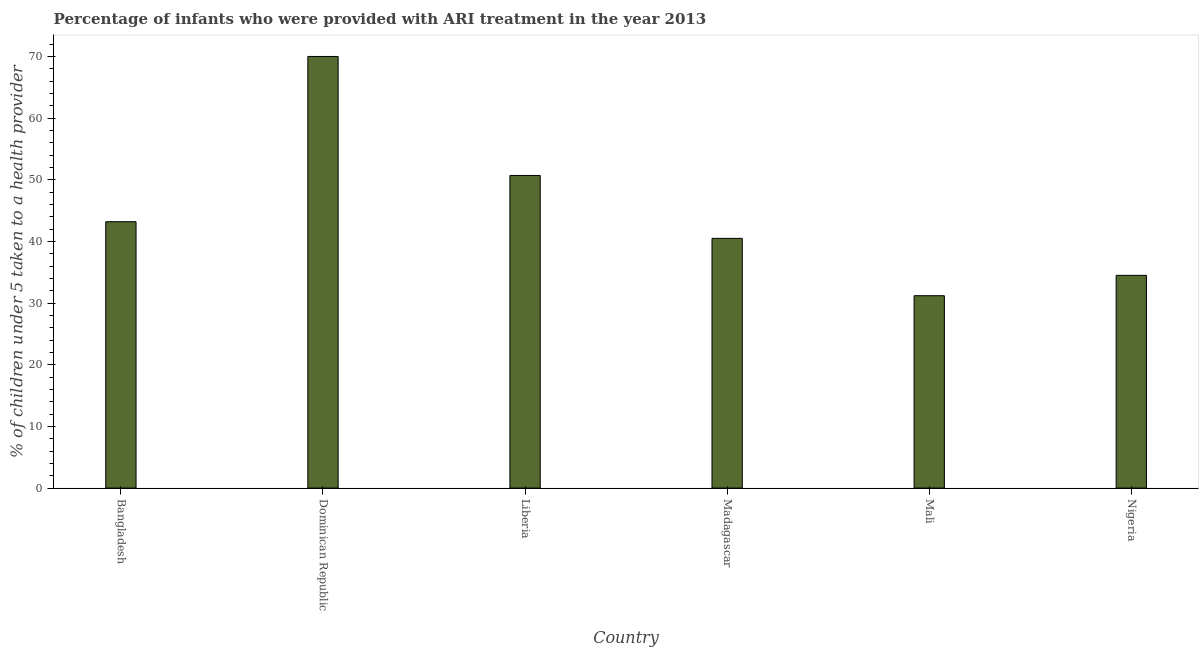Does the graph contain any zero values?
Provide a short and direct response. No. Does the graph contain grids?
Provide a succinct answer. No. What is the title of the graph?
Provide a short and direct response. Percentage of infants who were provided with ARI treatment in the year 2013. What is the label or title of the X-axis?
Give a very brief answer. Country. What is the label or title of the Y-axis?
Provide a short and direct response. % of children under 5 taken to a health provider. What is the percentage of children who were provided with ari treatment in Madagascar?
Offer a very short reply. 40.5. Across all countries, what is the minimum percentage of children who were provided with ari treatment?
Give a very brief answer. 31.2. In which country was the percentage of children who were provided with ari treatment maximum?
Ensure brevity in your answer.  Dominican Republic. In which country was the percentage of children who were provided with ari treatment minimum?
Offer a terse response. Mali. What is the sum of the percentage of children who were provided with ari treatment?
Ensure brevity in your answer.  270.1. What is the average percentage of children who were provided with ari treatment per country?
Make the answer very short. 45.02. What is the median percentage of children who were provided with ari treatment?
Your answer should be very brief. 41.85. In how many countries, is the percentage of children who were provided with ari treatment greater than 60 %?
Your answer should be very brief. 1. What is the ratio of the percentage of children who were provided with ari treatment in Bangladesh to that in Nigeria?
Your response must be concise. 1.25. What is the difference between the highest and the second highest percentage of children who were provided with ari treatment?
Keep it short and to the point. 19.3. Is the sum of the percentage of children who were provided with ari treatment in Madagascar and Mali greater than the maximum percentage of children who were provided with ari treatment across all countries?
Your answer should be compact. Yes. What is the difference between the highest and the lowest percentage of children who were provided with ari treatment?
Give a very brief answer. 38.8. In how many countries, is the percentage of children who were provided with ari treatment greater than the average percentage of children who were provided with ari treatment taken over all countries?
Offer a very short reply. 2. How many bars are there?
Provide a short and direct response. 6. Are all the bars in the graph horizontal?
Your response must be concise. No. How many countries are there in the graph?
Your answer should be very brief. 6. What is the difference between two consecutive major ticks on the Y-axis?
Your answer should be compact. 10. What is the % of children under 5 taken to a health provider in Bangladesh?
Keep it short and to the point. 43.2. What is the % of children under 5 taken to a health provider of Dominican Republic?
Ensure brevity in your answer.  70. What is the % of children under 5 taken to a health provider in Liberia?
Keep it short and to the point. 50.7. What is the % of children under 5 taken to a health provider in Madagascar?
Make the answer very short. 40.5. What is the % of children under 5 taken to a health provider of Mali?
Your answer should be very brief. 31.2. What is the % of children under 5 taken to a health provider in Nigeria?
Your answer should be very brief. 34.5. What is the difference between the % of children under 5 taken to a health provider in Bangladesh and Dominican Republic?
Your answer should be very brief. -26.8. What is the difference between the % of children under 5 taken to a health provider in Bangladesh and Madagascar?
Offer a terse response. 2.7. What is the difference between the % of children under 5 taken to a health provider in Bangladesh and Mali?
Offer a terse response. 12. What is the difference between the % of children under 5 taken to a health provider in Bangladesh and Nigeria?
Provide a succinct answer. 8.7. What is the difference between the % of children under 5 taken to a health provider in Dominican Republic and Liberia?
Your answer should be compact. 19.3. What is the difference between the % of children under 5 taken to a health provider in Dominican Republic and Madagascar?
Provide a succinct answer. 29.5. What is the difference between the % of children under 5 taken to a health provider in Dominican Republic and Mali?
Offer a very short reply. 38.8. What is the difference between the % of children under 5 taken to a health provider in Dominican Republic and Nigeria?
Your answer should be compact. 35.5. What is the difference between the % of children under 5 taken to a health provider in Liberia and Madagascar?
Your response must be concise. 10.2. What is the difference between the % of children under 5 taken to a health provider in Liberia and Mali?
Your answer should be very brief. 19.5. What is the difference between the % of children under 5 taken to a health provider in Liberia and Nigeria?
Keep it short and to the point. 16.2. What is the difference between the % of children under 5 taken to a health provider in Madagascar and Mali?
Provide a succinct answer. 9.3. What is the difference between the % of children under 5 taken to a health provider in Madagascar and Nigeria?
Offer a terse response. 6. What is the ratio of the % of children under 5 taken to a health provider in Bangladesh to that in Dominican Republic?
Provide a succinct answer. 0.62. What is the ratio of the % of children under 5 taken to a health provider in Bangladesh to that in Liberia?
Your answer should be compact. 0.85. What is the ratio of the % of children under 5 taken to a health provider in Bangladesh to that in Madagascar?
Ensure brevity in your answer.  1.07. What is the ratio of the % of children under 5 taken to a health provider in Bangladesh to that in Mali?
Provide a short and direct response. 1.39. What is the ratio of the % of children under 5 taken to a health provider in Bangladesh to that in Nigeria?
Your answer should be compact. 1.25. What is the ratio of the % of children under 5 taken to a health provider in Dominican Republic to that in Liberia?
Keep it short and to the point. 1.38. What is the ratio of the % of children under 5 taken to a health provider in Dominican Republic to that in Madagascar?
Give a very brief answer. 1.73. What is the ratio of the % of children under 5 taken to a health provider in Dominican Republic to that in Mali?
Offer a very short reply. 2.24. What is the ratio of the % of children under 5 taken to a health provider in Dominican Republic to that in Nigeria?
Give a very brief answer. 2.03. What is the ratio of the % of children under 5 taken to a health provider in Liberia to that in Madagascar?
Ensure brevity in your answer.  1.25. What is the ratio of the % of children under 5 taken to a health provider in Liberia to that in Mali?
Give a very brief answer. 1.62. What is the ratio of the % of children under 5 taken to a health provider in Liberia to that in Nigeria?
Offer a very short reply. 1.47. What is the ratio of the % of children under 5 taken to a health provider in Madagascar to that in Mali?
Provide a short and direct response. 1.3. What is the ratio of the % of children under 5 taken to a health provider in Madagascar to that in Nigeria?
Ensure brevity in your answer.  1.17. What is the ratio of the % of children under 5 taken to a health provider in Mali to that in Nigeria?
Provide a succinct answer. 0.9. 